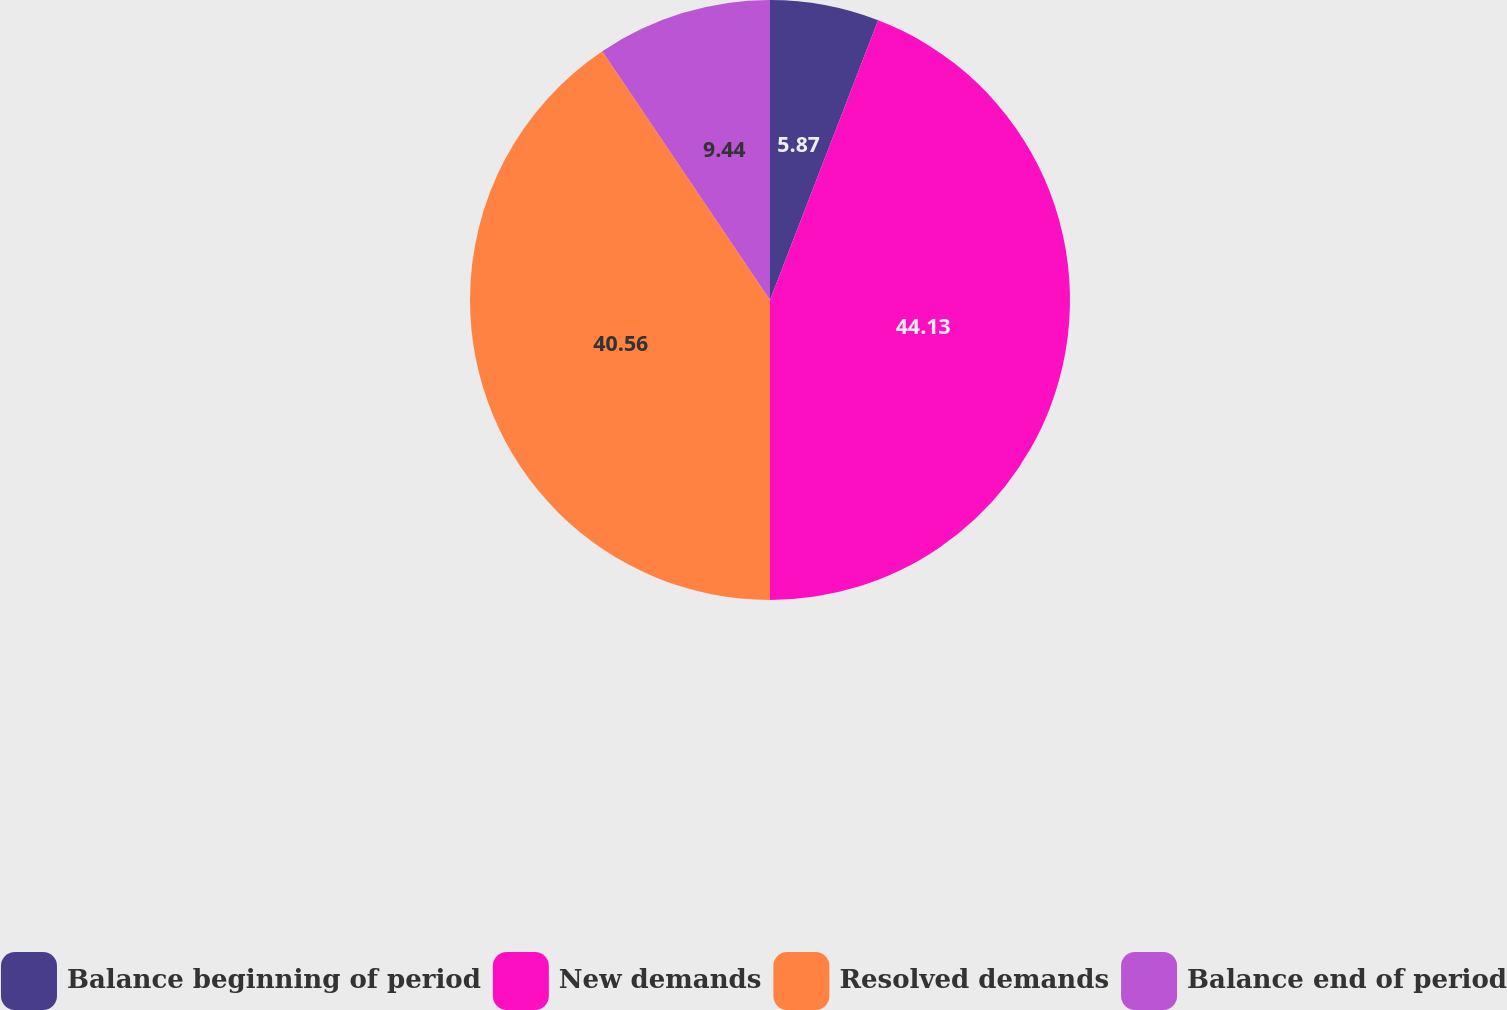<chart> <loc_0><loc_0><loc_500><loc_500><pie_chart><fcel>Balance beginning of period<fcel>New demands<fcel>Resolved demands<fcel>Balance end of period<nl><fcel>5.87%<fcel>44.13%<fcel>40.56%<fcel>9.44%<nl></chart> 